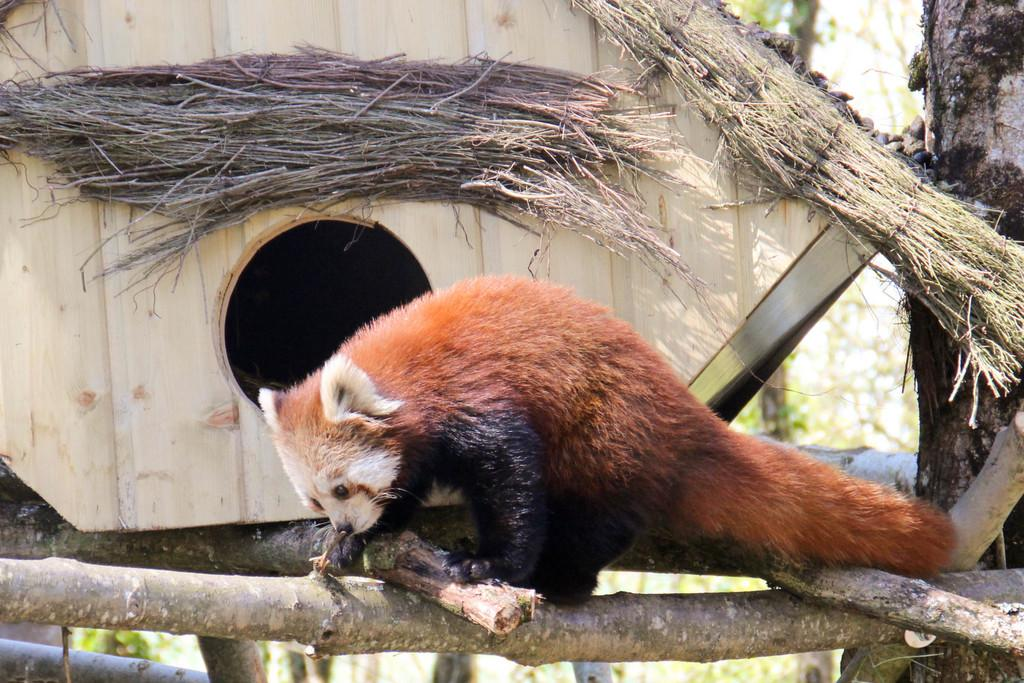What type of animal can be seen in the image? There is an animal in the image, but its specific type cannot be determined from the provided facts. Where is the animal located in relation to the pet house? The animal is in front of a pet house in the image. What can be seen in the background of the image? There are trees in the background of the image. What type of tooth is visible in the image? There is no tooth visible in the image. Can you describe the ocean in the image? There is no ocean present in the image. 